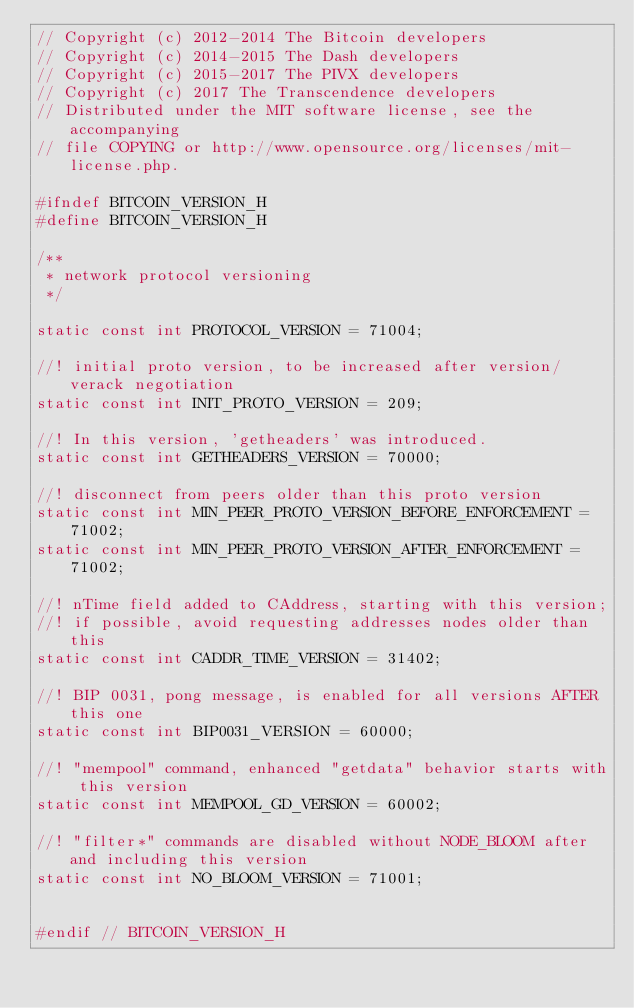Convert code to text. <code><loc_0><loc_0><loc_500><loc_500><_C_>// Copyright (c) 2012-2014 The Bitcoin developers
// Copyright (c) 2014-2015 The Dash developers
// Copyright (c) 2015-2017 The PIVX developers
// Copyright (c) 2017 The Transcendence developers
// Distributed under the MIT software license, see the accompanying
// file COPYING or http://www.opensource.org/licenses/mit-license.php.

#ifndef BITCOIN_VERSION_H
#define BITCOIN_VERSION_H

/**
 * network protocol versioning
 */

static const int PROTOCOL_VERSION = 71004;

//! initial proto version, to be increased after version/verack negotiation
static const int INIT_PROTO_VERSION = 209;

//! In this version, 'getheaders' was introduced.
static const int GETHEADERS_VERSION = 70000;

//! disconnect from peers older than this proto version
static const int MIN_PEER_PROTO_VERSION_BEFORE_ENFORCEMENT = 71002;
static const int MIN_PEER_PROTO_VERSION_AFTER_ENFORCEMENT = 71002;

//! nTime field added to CAddress, starting with this version;
//! if possible, avoid requesting addresses nodes older than this
static const int CADDR_TIME_VERSION = 31402;

//! BIP 0031, pong message, is enabled for all versions AFTER this one
static const int BIP0031_VERSION = 60000;

//! "mempool" command, enhanced "getdata" behavior starts with this version
static const int MEMPOOL_GD_VERSION = 60002;

//! "filter*" commands are disabled without NODE_BLOOM after and including this version
static const int NO_BLOOM_VERSION = 71001;


#endif // BITCOIN_VERSION_H
</code> 